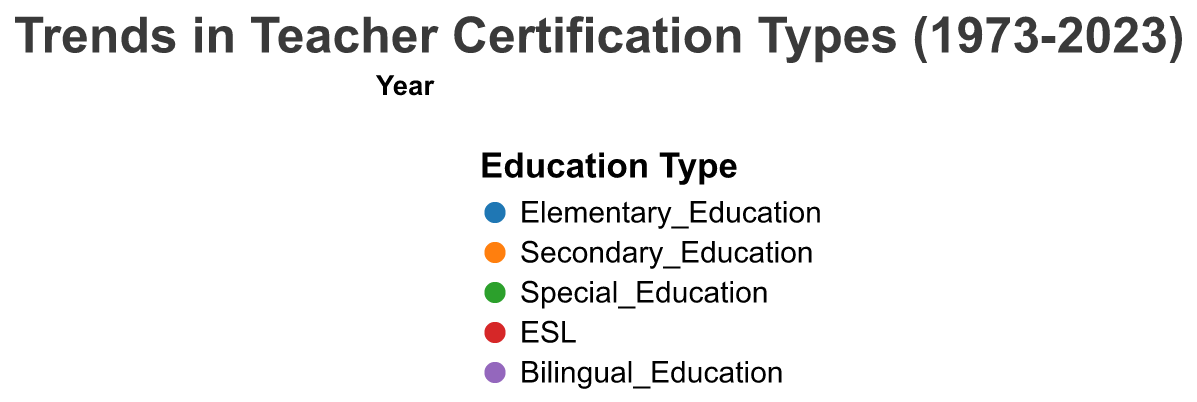What is the title of the figure? The title is located at the top of the figure in a larger and bold font compared to other text. It provides an immediate understanding of what the figure represents.
Answer: "Trends in Teacher Certification Types (1973-2023)" How do the percentages of Traditional and Alternative certifications in Elementary Education compare in 2023? To find the answer, look at the corresponding segments within the 2023 subplot. Compare the sizes of the segments for Traditional (45%) and Alternative (25%).
Answer: Traditional is higher Which year has the highest percentage of Alternative certifications in Special Education? Review each subplot's Special Education segment for Alternative certifications across all years and identify the highest percentage. In 2023, Alternative certifications accounted for 20%, which is the maximum across the observed years.
Answer: 2023 In which year did Alternative certifications in Bilingual Education double compared to the previous decade? Check the percentage of Alternative certifications in Bilingual Education for each year. Identify the years where the percentage doubled from the previous decade. 2013 (5%) doubled from 2003 (4%), but 2023 (6%) doubling from 2013 (5%) is more distinct.
Answer: 2023 What trend is observed in the percentage of Traditional certifications in Secondary Education from 1973 to 2023? Observe the segment for Traditional certifications in Secondary Education across all subplots. The percentages decrease from 65% in 1973 to 55% in 2023.
Answer: Decreasing trend Between Traditional and Alternative certifications, which shows a general increase in ESL certifications from 1973 to 2023? Inspect the ESL segments for both certification types over the years. Compare the changes. Traditional certifications generally remain unchanged (around 10%), whereas Alternative shows an increasing trend (from 1% to 12%).
Answer: Alternative certifications What year had the closest percentages between Traditional and Alternative certifications in Elementary Education? Compare the Elementary Education segments for both certification types across all years. In 2023, Traditional had 45%, and Alternative had 25%, the smallest gap observed.
Answer: 2023 Which type of certification shows a more rapid growth rate in Special Education from 1973 to 2023? Compare the relative increase in the percentages of Traditional versus Alternative certifications in Special Education. Traditional certifications grow from 30% to 25% (even decreasing), while Alternative grows from 5% to 20%.
Answer: Alternative certifications 